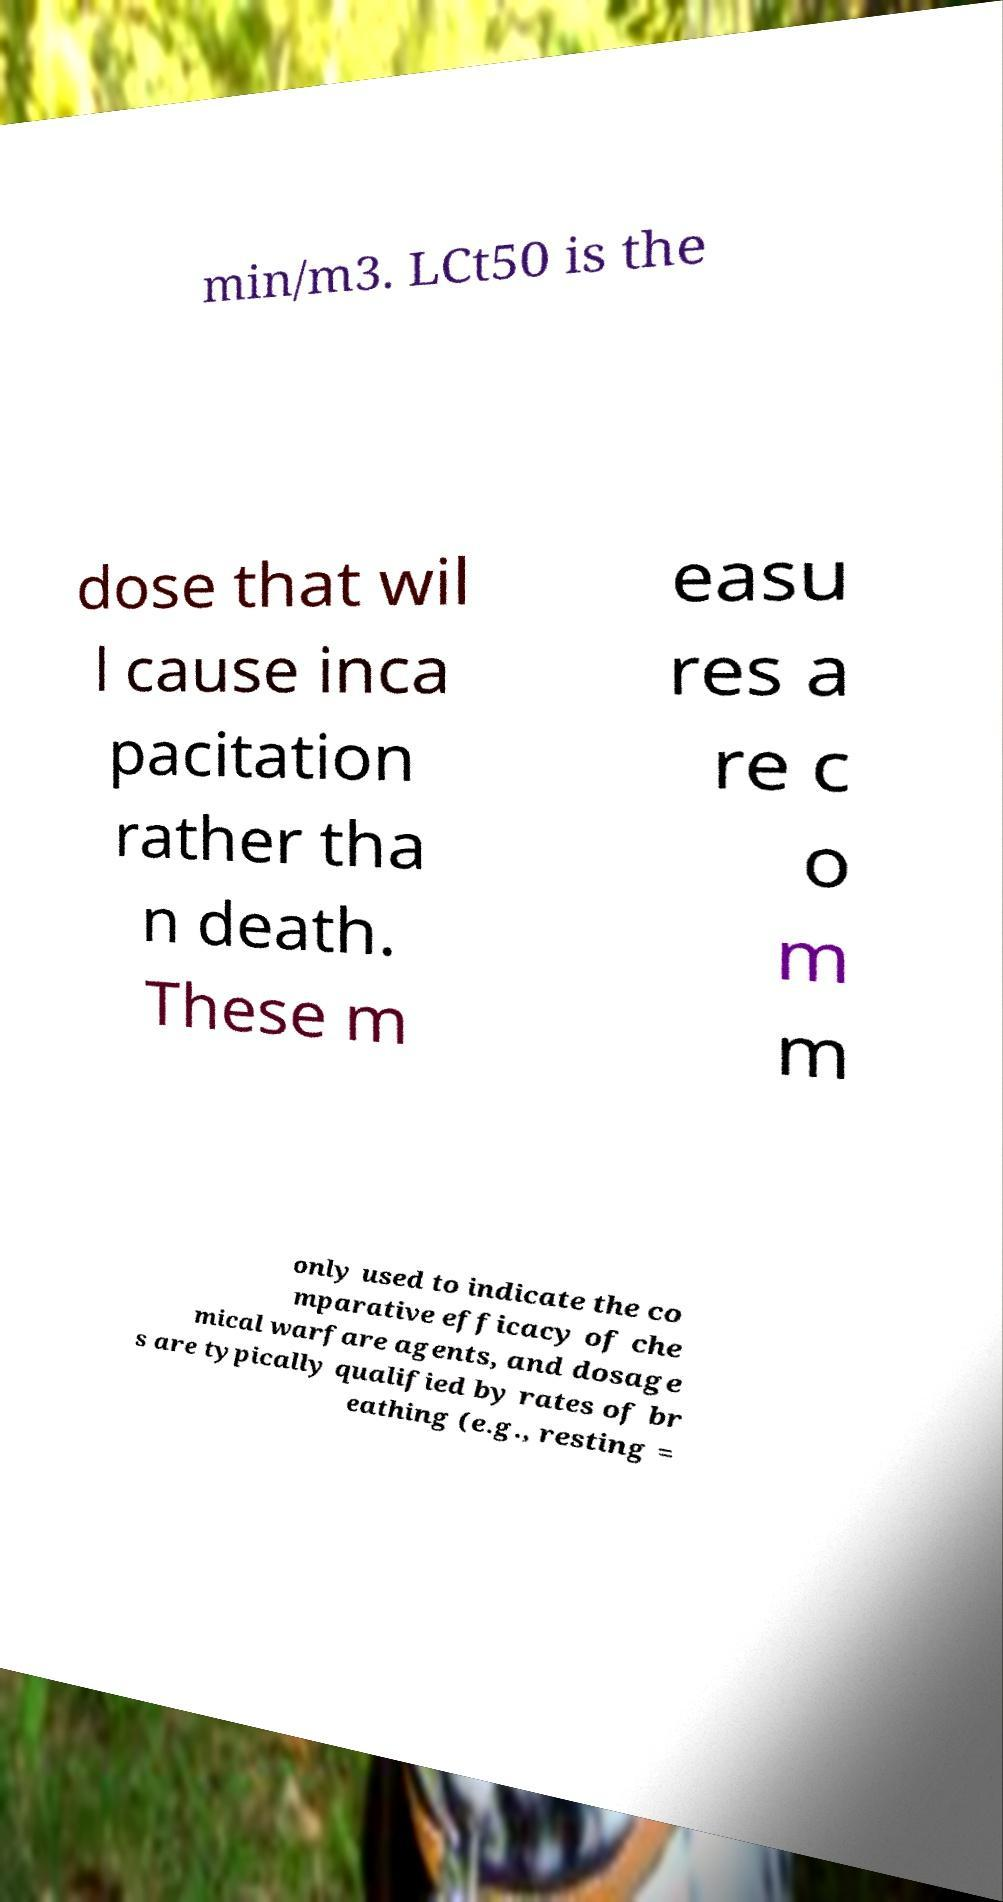For documentation purposes, I need the text within this image transcribed. Could you provide that? min/m3. LCt50 is the dose that wil l cause inca pacitation rather tha n death. These m easu res a re c o m m only used to indicate the co mparative efficacy of che mical warfare agents, and dosage s are typically qualified by rates of br eathing (e.g., resting = 